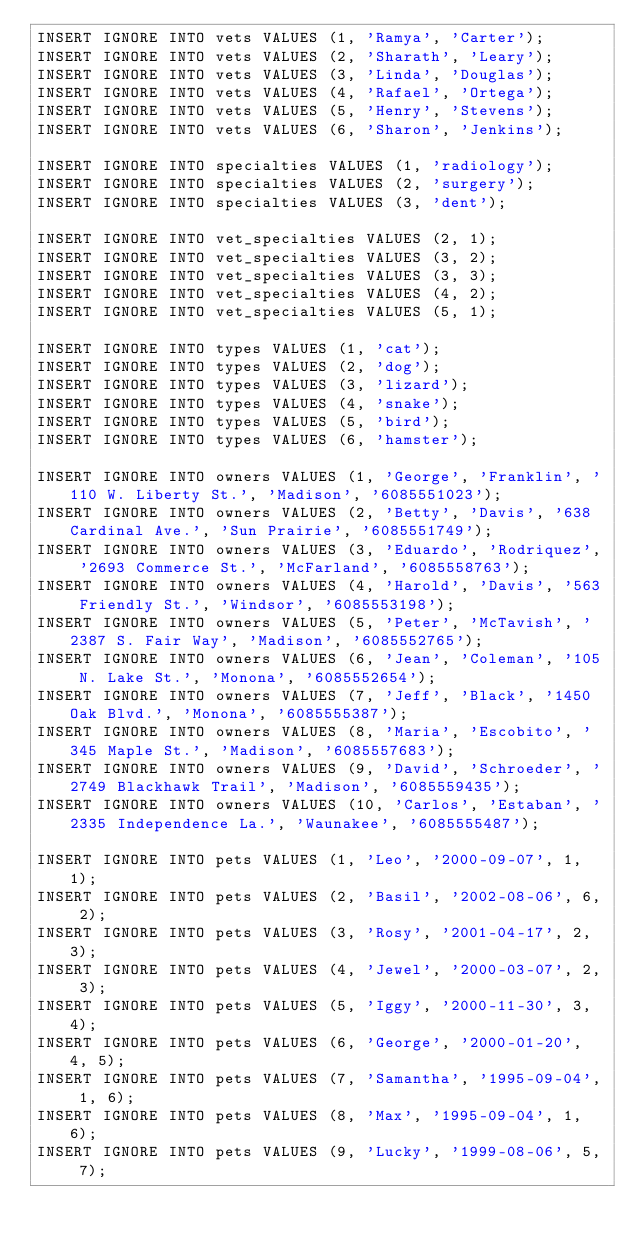Convert code to text. <code><loc_0><loc_0><loc_500><loc_500><_SQL_>INSERT IGNORE INTO vets VALUES (1, 'Ramya', 'Carter');
INSERT IGNORE INTO vets VALUES (2, 'Sharath', 'Leary');
INSERT IGNORE INTO vets VALUES (3, 'Linda', 'Douglas');
INSERT IGNORE INTO vets VALUES (4, 'Rafael', 'Ortega');
INSERT IGNORE INTO vets VALUES (5, 'Henry', 'Stevens');
INSERT IGNORE INTO vets VALUES (6, 'Sharon', 'Jenkins');

INSERT IGNORE INTO specialties VALUES (1, 'radiology');
INSERT IGNORE INTO specialties VALUES (2, 'surgery');
INSERT IGNORE INTO specialties VALUES (3, 'dent');

INSERT IGNORE INTO vet_specialties VALUES (2, 1);
INSERT IGNORE INTO vet_specialties VALUES (3, 2);
INSERT IGNORE INTO vet_specialties VALUES (3, 3);
INSERT IGNORE INTO vet_specialties VALUES (4, 2);
INSERT IGNORE INTO vet_specialties VALUES (5, 1);

INSERT IGNORE INTO types VALUES (1, 'cat');
INSERT IGNORE INTO types VALUES (2, 'dog');
INSERT IGNORE INTO types VALUES (3, 'lizard');
INSERT IGNORE INTO types VALUES (4, 'snake');
INSERT IGNORE INTO types VALUES (5, 'bird');
INSERT IGNORE INTO types VALUES (6, 'hamster');

INSERT IGNORE INTO owners VALUES (1, 'George', 'Franklin', '110 W. Liberty St.', 'Madison', '6085551023');
INSERT IGNORE INTO owners VALUES (2, 'Betty', 'Davis', '638 Cardinal Ave.', 'Sun Prairie', '6085551749');
INSERT IGNORE INTO owners VALUES (3, 'Eduardo', 'Rodriquez', '2693 Commerce St.', 'McFarland', '6085558763');
INSERT IGNORE INTO owners VALUES (4, 'Harold', 'Davis', '563 Friendly St.', 'Windsor', '6085553198');
INSERT IGNORE INTO owners VALUES (5, 'Peter', 'McTavish', '2387 S. Fair Way', 'Madison', '6085552765');
INSERT IGNORE INTO owners VALUES (6, 'Jean', 'Coleman', '105 N. Lake St.', 'Monona', '6085552654');
INSERT IGNORE INTO owners VALUES (7, 'Jeff', 'Black', '1450 Oak Blvd.', 'Monona', '6085555387');
INSERT IGNORE INTO owners VALUES (8, 'Maria', 'Escobito', '345 Maple St.', 'Madison', '6085557683');
INSERT IGNORE INTO owners VALUES (9, 'David', 'Schroeder', '2749 Blackhawk Trail', 'Madison', '6085559435');
INSERT IGNORE INTO owners VALUES (10, 'Carlos', 'Estaban', '2335 Independence La.', 'Waunakee', '6085555487');

INSERT IGNORE INTO pets VALUES (1, 'Leo', '2000-09-07', 1, 1);
INSERT IGNORE INTO pets VALUES (2, 'Basil', '2002-08-06', 6, 2);
INSERT IGNORE INTO pets VALUES (3, 'Rosy', '2001-04-17', 2, 3);
INSERT IGNORE INTO pets VALUES (4, 'Jewel', '2000-03-07', 2, 3);
INSERT IGNORE INTO pets VALUES (5, 'Iggy', '2000-11-30', 3, 4);
INSERT IGNORE INTO pets VALUES (6, 'George', '2000-01-20', 4, 5);
INSERT IGNORE INTO pets VALUES (7, 'Samantha', '1995-09-04', 1, 6);
INSERT IGNORE INTO pets VALUES (8, 'Max', '1995-09-04', 1, 6);
INSERT IGNORE INTO pets VALUES (9, 'Lucky', '1999-08-06', 5, 7);</code> 